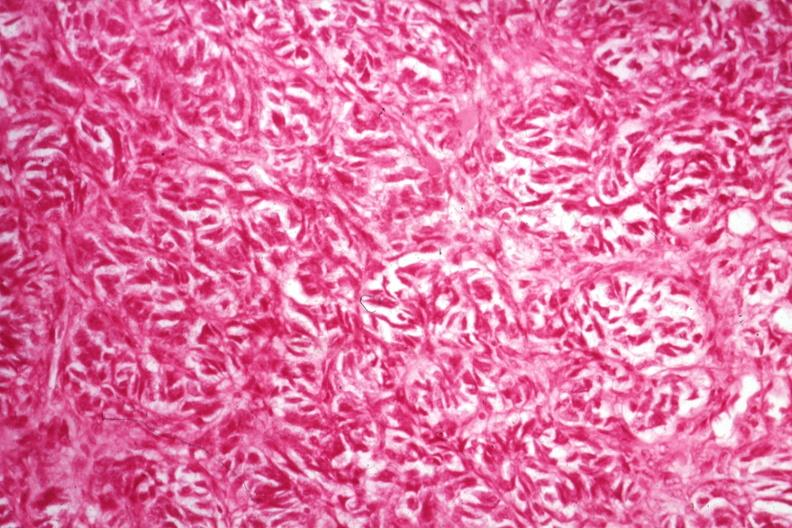s ovary present?
Answer the question using a single word or phrase. Yes 